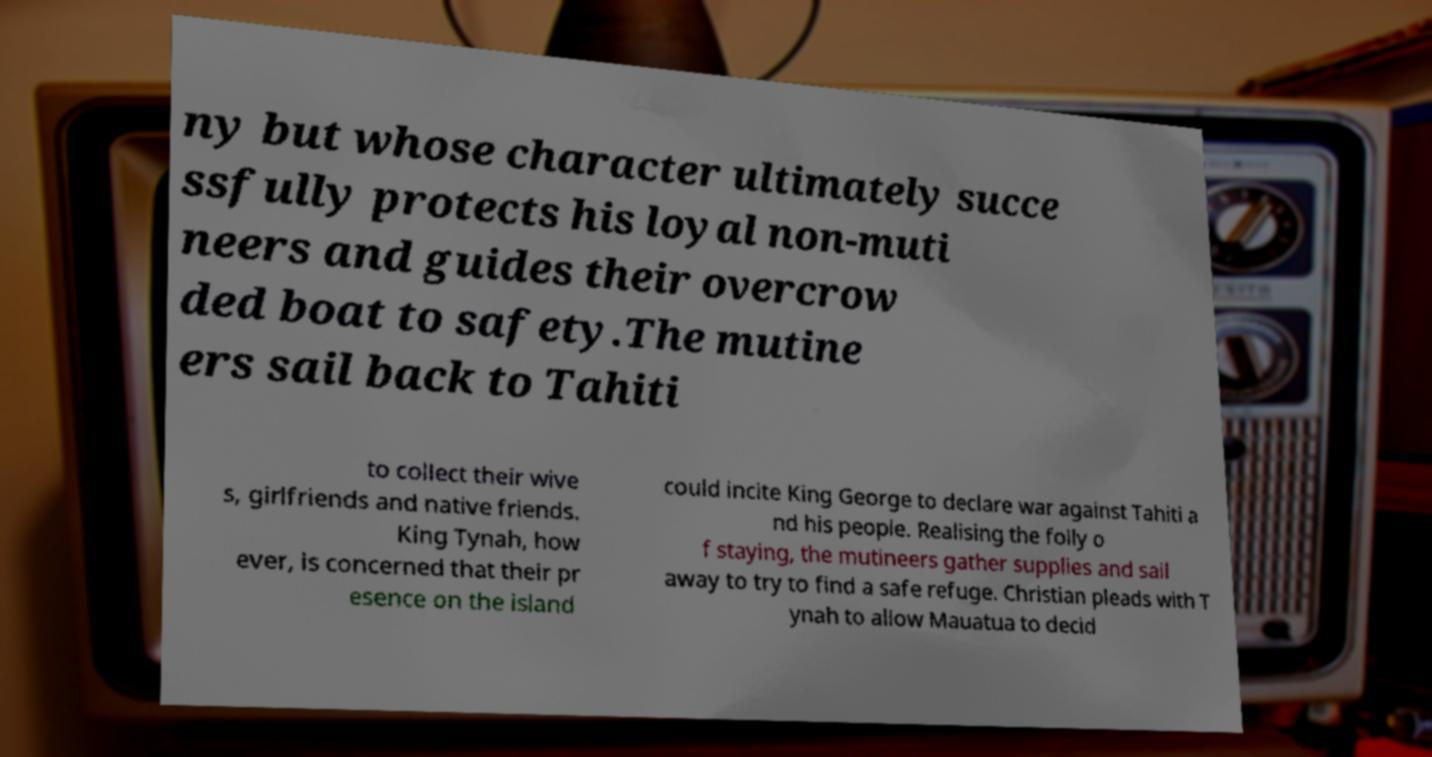Can you read and provide the text displayed in the image?This photo seems to have some interesting text. Can you extract and type it out for me? ny but whose character ultimately succe ssfully protects his loyal non-muti neers and guides their overcrow ded boat to safety.The mutine ers sail back to Tahiti to collect their wive s, girlfriends and native friends. King Tynah, how ever, is concerned that their pr esence on the island could incite King George to declare war against Tahiti a nd his people. Realising the folly o f staying, the mutineers gather supplies and sail away to try to find a safe refuge. Christian pleads with T ynah to allow Mauatua to decid 